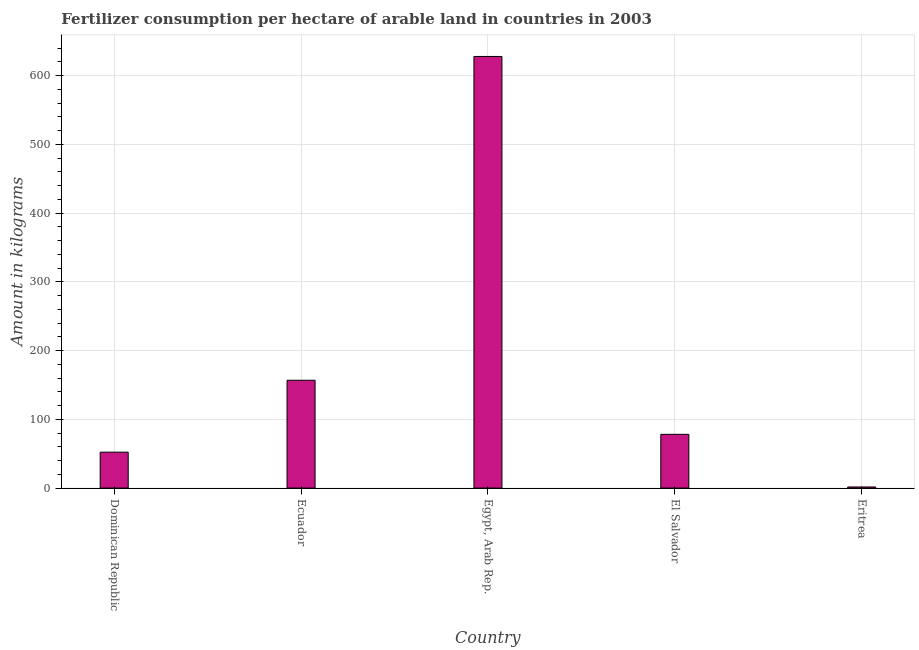What is the title of the graph?
Give a very brief answer. Fertilizer consumption per hectare of arable land in countries in 2003 . What is the label or title of the Y-axis?
Offer a terse response. Amount in kilograms. What is the amount of fertilizer consumption in El Salvador?
Give a very brief answer. 78.19. Across all countries, what is the maximum amount of fertilizer consumption?
Your response must be concise. 627.75. Across all countries, what is the minimum amount of fertilizer consumption?
Offer a terse response. 1.63. In which country was the amount of fertilizer consumption maximum?
Your answer should be compact. Egypt, Arab Rep. In which country was the amount of fertilizer consumption minimum?
Offer a terse response. Eritrea. What is the sum of the amount of fertilizer consumption?
Your answer should be very brief. 916.63. What is the difference between the amount of fertilizer consumption in Ecuador and El Salvador?
Your answer should be compact. 78.64. What is the average amount of fertilizer consumption per country?
Your answer should be compact. 183.33. What is the median amount of fertilizer consumption?
Keep it short and to the point. 78.19. In how many countries, is the amount of fertilizer consumption greater than 340 kg?
Give a very brief answer. 1. What is the ratio of the amount of fertilizer consumption in Dominican Republic to that in Eritrea?
Give a very brief answer. 32.09. Is the amount of fertilizer consumption in Ecuador less than that in Eritrea?
Give a very brief answer. No. What is the difference between the highest and the second highest amount of fertilizer consumption?
Make the answer very short. 470.93. What is the difference between the highest and the lowest amount of fertilizer consumption?
Give a very brief answer. 626.12. Are all the bars in the graph horizontal?
Provide a succinct answer. No. How many countries are there in the graph?
Your answer should be compact. 5. What is the difference between two consecutive major ticks on the Y-axis?
Give a very brief answer. 100. What is the Amount in kilograms in Dominican Republic?
Provide a succinct answer. 52.24. What is the Amount in kilograms in Ecuador?
Provide a succinct answer. 156.82. What is the Amount in kilograms of Egypt, Arab Rep.?
Provide a short and direct response. 627.75. What is the Amount in kilograms of El Salvador?
Make the answer very short. 78.19. What is the Amount in kilograms of Eritrea?
Offer a terse response. 1.63. What is the difference between the Amount in kilograms in Dominican Republic and Ecuador?
Offer a terse response. -104.58. What is the difference between the Amount in kilograms in Dominican Republic and Egypt, Arab Rep.?
Offer a very short reply. -575.51. What is the difference between the Amount in kilograms in Dominican Republic and El Salvador?
Offer a terse response. -25.94. What is the difference between the Amount in kilograms in Dominican Republic and Eritrea?
Ensure brevity in your answer.  50.61. What is the difference between the Amount in kilograms in Ecuador and Egypt, Arab Rep.?
Your answer should be very brief. -470.93. What is the difference between the Amount in kilograms in Ecuador and El Salvador?
Keep it short and to the point. 78.64. What is the difference between the Amount in kilograms in Ecuador and Eritrea?
Ensure brevity in your answer.  155.19. What is the difference between the Amount in kilograms in Egypt, Arab Rep. and El Salvador?
Your response must be concise. 549.56. What is the difference between the Amount in kilograms in Egypt, Arab Rep. and Eritrea?
Keep it short and to the point. 626.12. What is the difference between the Amount in kilograms in El Salvador and Eritrea?
Make the answer very short. 76.56. What is the ratio of the Amount in kilograms in Dominican Republic to that in Ecuador?
Your response must be concise. 0.33. What is the ratio of the Amount in kilograms in Dominican Republic to that in Egypt, Arab Rep.?
Provide a succinct answer. 0.08. What is the ratio of the Amount in kilograms in Dominican Republic to that in El Salvador?
Make the answer very short. 0.67. What is the ratio of the Amount in kilograms in Dominican Republic to that in Eritrea?
Offer a terse response. 32.09. What is the ratio of the Amount in kilograms in Ecuador to that in El Salvador?
Make the answer very short. 2.01. What is the ratio of the Amount in kilograms in Ecuador to that in Eritrea?
Your answer should be very brief. 96.32. What is the ratio of the Amount in kilograms in Egypt, Arab Rep. to that in El Salvador?
Your response must be concise. 8.03. What is the ratio of the Amount in kilograms in Egypt, Arab Rep. to that in Eritrea?
Your answer should be very brief. 385.56. What is the ratio of the Amount in kilograms in El Salvador to that in Eritrea?
Provide a short and direct response. 48.02. 